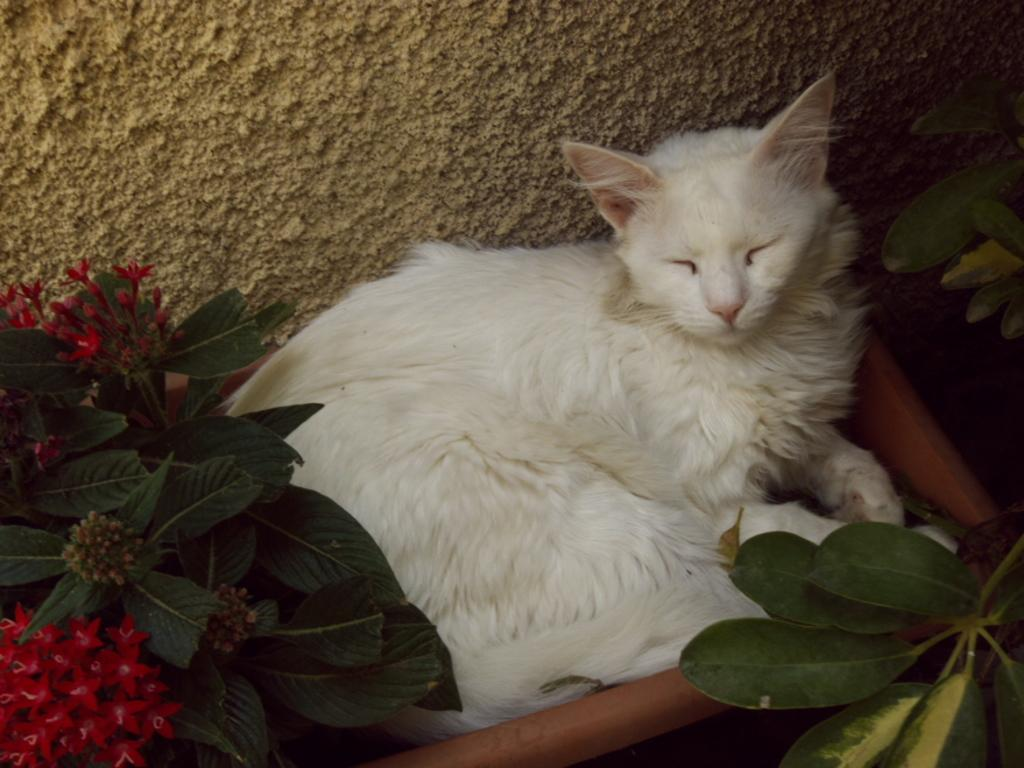What type of animal is in the image? There is a white-colored cat in the image. Where is the cat located in the image? The cat is present over a place. What other living organisms can be seen in the image? There are plants present in the image. What type of mouth can be seen on the cat in the image? There is no mouth visible on the cat in the image, as cats do not have human-like mouths. 